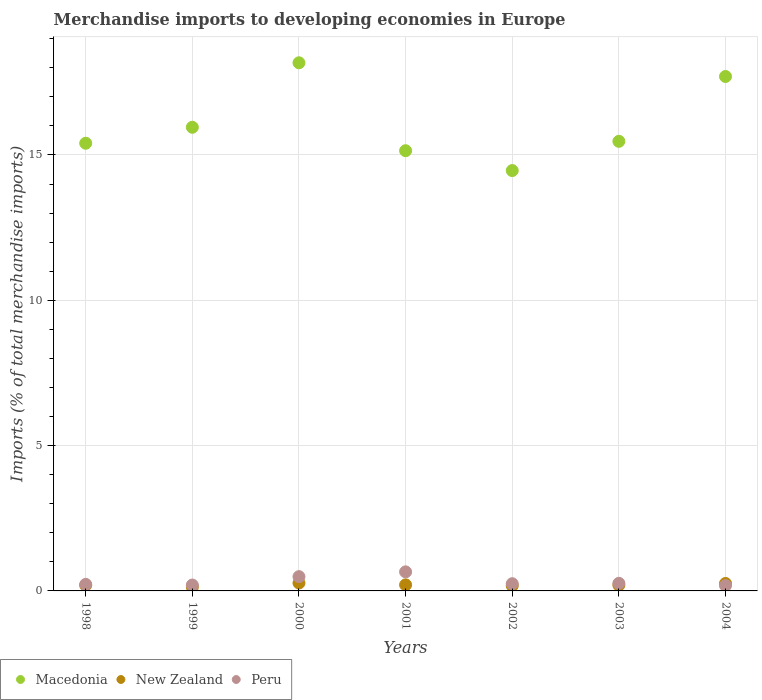How many different coloured dotlines are there?
Your answer should be compact. 3. Is the number of dotlines equal to the number of legend labels?
Your response must be concise. Yes. What is the percentage total merchandise imports in Macedonia in 2003?
Provide a short and direct response. 15.47. Across all years, what is the maximum percentage total merchandise imports in Peru?
Make the answer very short. 0.66. Across all years, what is the minimum percentage total merchandise imports in New Zealand?
Provide a succinct answer. 0.13. What is the total percentage total merchandise imports in Peru in the graph?
Your answer should be compact. 2.27. What is the difference between the percentage total merchandise imports in New Zealand in 1999 and that in 2002?
Your response must be concise. -0.05. What is the difference between the percentage total merchandise imports in Peru in 2002 and the percentage total merchandise imports in Macedonia in 2001?
Your answer should be very brief. -14.9. What is the average percentage total merchandise imports in Macedonia per year?
Your response must be concise. 16.04. In the year 2004, what is the difference between the percentage total merchandise imports in New Zealand and percentage total merchandise imports in Macedonia?
Your answer should be very brief. -17.44. In how many years, is the percentage total merchandise imports in Peru greater than 3 %?
Offer a very short reply. 0. What is the ratio of the percentage total merchandise imports in Macedonia in 1999 to that in 2004?
Your response must be concise. 0.9. What is the difference between the highest and the second highest percentage total merchandise imports in Peru?
Your answer should be very brief. 0.16. What is the difference between the highest and the lowest percentage total merchandise imports in Peru?
Make the answer very short. 0.47. In how many years, is the percentage total merchandise imports in New Zealand greater than the average percentage total merchandise imports in New Zealand taken over all years?
Your response must be concise. 3. Is the sum of the percentage total merchandise imports in Macedonia in 1999 and 2002 greater than the maximum percentage total merchandise imports in New Zealand across all years?
Provide a short and direct response. Yes. Is it the case that in every year, the sum of the percentage total merchandise imports in New Zealand and percentage total merchandise imports in Macedonia  is greater than the percentage total merchandise imports in Peru?
Give a very brief answer. Yes. Does the percentage total merchandise imports in New Zealand monotonically increase over the years?
Your answer should be compact. No. Are the values on the major ticks of Y-axis written in scientific E-notation?
Offer a very short reply. No. Does the graph contain any zero values?
Your response must be concise. No. Where does the legend appear in the graph?
Ensure brevity in your answer.  Bottom left. What is the title of the graph?
Provide a short and direct response. Merchandise imports to developing economies in Europe. Does "Belarus" appear as one of the legend labels in the graph?
Give a very brief answer. No. What is the label or title of the Y-axis?
Offer a terse response. Imports (% of total merchandise imports). What is the Imports (% of total merchandise imports) of Macedonia in 1998?
Ensure brevity in your answer.  15.4. What is the Imports (% of total merchandise imports) of New Zealand in 1998?
Provide a short and direct response. 0.19. What is the Imports (% of total merchandise imports) in Peru in 1998?
Ensure brevity in your answer.  0.23. What is the Imports (% of total merchandise imports) of Macedonia in 1999?
Offer a very short reply. 15.95. What is the Imports (% of total merchandise imports) in New Zealand in 1999?
Give a very brief answer. 0.13. What is the Imports (% of total merchandise imports) in Peru in 1999?
Make the answer very short. 0.2. What is the Imports (% of total merchandise imports) in Macedonia in 2000?
Offer a terse response. 18.17. What is the Imports (% of total merchandise imports) in New Zealand in 2000?
Give a very brief answer. 0.27. What is the Imports (% of total merchandise imports) in Peru in 2000?
Offer a terse response. 0.49. What is the Imports (% of total merchandise imports) of Macedonia in 2001?
Offer a very short reply. 15.15. What is the Imports (% of total merchandise imports) of New Zealand in 2001?
Your answer should be very brief. 0.21. What is the Imports (% of total merchandise imports) in Peru in 2001?
Your answer should be compact. 0.66. What is the Imports (% of total merchandise imports) in Macedonia in 2002?
Your answer should be compact. 14.46. What is the Imports (% of total merchandise imports) in New Zealand in 2002?
Give a very brief answer. 0.18. What is the Imports (% of total merchandise imports) of Peru in 2002?
Offer a terse response. 0.25. What is the Imports (% of total merchandise imports) in Macedonia in 2003?
Offer a terse response. 15.47. What is the Imports (% of total merchandise imports) in New Zealand in 2003?
Offer a very short reply. 0.2. What is the Imports (% of total merchandise imports) of Peru in 2003?
Your answer should be compact. 0.26. What is the Imports (% of total merchandise imports) of Macedonia in 2004?
Your response must be concise. 17.7. What is the Imports (% of total merchandise imports) in New Zealand in 2004?
Provide a short and direct response. 0.26. What is the Imports (% of total merchandise imports) of Peru in 2004?
Give a very brief answer. 0.18. Across all years, what is the maximum Imports (% of total merchandise imports) of Macedonia?
Your answer should be very brief. 18.17. Across all years, what is the maximum Imports (% of total merchandise imports) of New Zealand?
Offer a very short reply. 0.27. Across all years, what is the maximum Imports (% of total merchandise imports) in Peru?
Your answer should be compact. 0.66. Across all years, what is the minimum Imports (% of total merchandise imports) of Macedonia?
Your answer should be compact. 14.46. Across all years, what is the minimum Imports (% of total merchandise imports) in New Zealand?
Offer a terse response. 0.13. Across all years, what is the minimum Imports (% of total merchandise imports) of Peru?
Your answer should be compact. 0.18. What is the total Imports (% of total merchandise imports) in Macedonia in the graph?
Offer a very short reply. 112.31. What is the total Imports (% of total merchandise imports) of New Zealand in the graph?
Offer a terse response. 1.44. What is the total Imports (% of total merchandise imports) of Peru in the graph?
Ensure brevity in your answer.  2.27. What is the difference between the Imports (% of total merchandise imports) in Macedonia in 1998 and that in 1999?
Give a very brief answer. -0.55. What is the difference between the Imports (% of total merchandise imports) of New Zealand in 1998 and that in 1999?
Keep it short and to the point. 0.06. What is the difference between the Imports (% of total merchandise imports) in Peru in 1998 and that in 1999?
Offer a terse response. 0.02. What is the difference between the Imports (% of total merchandise imports) of Macedonia in 1998 and that in 2000?
Make the answer very short. -2.77. What is the difference between the Imports (% of total merchandise imports) in New Zealand in 1998 and that in 2000?
Offer a terse response. -0.08. What is the difference between the Imports (% of total merchandise imports) in Peru in 1998 and that in 2000?
Offer a very short reply. -0.27. What is the difference between the Imports (% of total merchandise imports) of Macedonia in 1998 and that in 2001?
Your answer should be compact. 0.26. What is the difference between the Imports (% of total merchandise imports) of New Zealand in 1998 and that in 2001?
Give a very brief answer. -0.01. What is the difference between the Imports (% of total merchandise imports) of Peru in 1998 and that in 2001?
Your answer should be very brief. -0.43. What is the difference between the Imports (% of total merchandise imports) in Macedonia in 1998 and that in 2002?
Offer a terse response. 0.94. What is the difference between the Imports (% of total merchandise imports) in New Zealand in 1998 and that in 2002?
Your answer should be compact. 0.01. What is the difference between the Imports (% of total merchandise imports) in Peru in 1998 and that in 2002?
Ensure brevity in your answer.  -0.02. What is the difference between the Imports (% of total merchandise imports) in Macedonia in 1998 and that in 2003?
Make the answer very short. -0.07. What is the difference between the Imports (% of total merchandise imports) of New Zealand in 1998 and that in 2003?
Provide a succinct answer. -0. What is the difference between the Imports (% of total merchandise imports) in Peru in 1998 and that in 2003?
Make the answer very short. -0.04. What is the difference between the Imports (% of total merchandise imports) of Macedonia in 1998 and that in 2004?
Provide a succinct answer. -2.3. What is the difference between the Imports (% of total merchandise imports) of New Zealand in 1998 and that in 2004?
Ensure brevity in your answer.  -0.06. What is the difference between the Imports (% of total merchandise imports) in Peru in 1998 and that in 2004?
Provide a succinct answer. 0.04. What is the difference between the Imports (% of total merchandise imports) in Macedonia in 1999 and that in 2000?
Offer a terse response. -2.22. What is the difference between the Imports (% of total merchandise imports) in New Zealand in 1999 and that in 2000?
Provide a succinct answer. -0.14. What is the difference between the Imports (% of total merchandise imports) in Peru in 1999 and that in 2000?
Your answer should be compact. -0.29. What is the difference between the Imports (% of total merchandise imports) in Macedonia in 1999 and that in 2001?
Offer a very short reply. 0.81. What is the difference between the Imports (% of total merchandise imports) in New Zealand in 1999 and that in 2001?
Give a very brief answer. -0.08. What is the difference between the Imports (% of total merchandise imports) in Peru in 1999 and that in 2001?
Offer a terse response. -0.45. What is the difference between the Imports (% of total merchandise imports) in Macedonia in 1999 and that in 2002?
Your answer should be compact. 1.49. What is the difference between the Imports (% of total merchandise imports) in New Zealand in 1999 and that in 2002?
Provide a short and direct response. -0.05. What is the difference between the Imports (% of total merchandise imports) of Peru in 1999 and that in 2002?
Offer a terse response. -0.05. What is the difference between the Imports (% of total merchandise imports) of Macedonia in 1999 and that in 2003?
Offer a terse response. 0.48. What is the difference between the Imports (% of total merchandise imports) of New Zealand in 1999 and that in 2003?
Your response must be concise. -0.07. What is the difference between the Imports (% of total merchandise imports) of Peru in 1999 and that in 2003?
Your answer should be compact. -0.06. What is the difference between the Imports (% of total merchandise imports) in Macedonia in 1999 and that in 2004?
Offer a terse response. -1.75. What is the difference between the Imports (% of total merchandise imports) in New Zealand in 1999 and that in 2004?
Make the answer very short. -0.12. What is the difference between the Imports (% of total merchandise imports) of Peru in 1999 and that in 2004?
Provide a short and direct response. 0.02. What is the difference between the Imports (% of total merchandise imports) in Macedonia in 2000 and that in 2001?
Your answer should be very brief. 3.03. What is the difference between the Imports (% of total merchandise imports) of New Zealand in 2000 and that in 2001?
Give a very brief answer. 0.06. What is the difference between the Imports (% of total merchandise imports) of Peru in 2000 and that in 2001?
Provide a succinct answer. -0.16. What is the difference between the Imports (% of total merchandise imports) of Macedonia in 2000 and that in 2002?
Give a very brief answer. 3.71. What is the difference between the Imports (% of total merchandise imports) in New Zealand in 2000 and that in 2002?
Offer a terse response. 0.09. What is the difference between the Imports (% of total merchandise imports) in Peru in 2000 and that in 2002?
Give a very brief answer. 0.24. What is the difference between the Imports (% of total merchandise imports) of Macedonia in 2000 and that in 2003?
Offer a very short reply. 2.7. What is the difference between the Imports (% of total merchandise imports) of New Zealand in 2000 and that in 2003?
Keep it short and to the point. 0.07. What is the difference between the Imports (% of total merchandise imports) of Peru in 2000 and that in 2003?
Keep it short and to the point. 0.23. What is the difference between the Imports (% of total merchandise imports) in Macedonia in 2000 and that in 2004?
Make the answer very short. 0.47. What is the difference between the Imports (% of total merchandise imports) of New Zealand in 2000 and that in 2004?
Keep it short and to the point. 0.02. What is the difference between the Imports (% of total merchandise imports) of Peru in 2000 and that in 2004?
Make the answer very short. 0.31. What is the difference between the Imports (% of total merchandise imports) of Macedonia in 2001 and that in 2002?
Offer a very short reply. 0.68. What is the difference between the Imports (% of total merchandise imports) of New Zealand in 2001 and that in 2002?
Your response must be concise. 0.03. What is the difference between the Imports (% of total merchandise imports) in Peru in 2001 and that in 2002?
Your response must be concise. 0.41. What is the difference between the Imports (% of total merchandise imports) in Macedonia in 2001 and that in 2003?
Keep it short and to the point. -0.32. What is the difference between the Imports (% of total merchandise imports) of New Zealand in 2001 and that in 2003?
Make the answer very short. 0.01. What is the difference between the Imports (% of total merchandise imports) in Peru in 2001 and that in 2003?
Provide a succinct answer. 0.39. What is the difference between the Imports (% of total merchandise imports) of Macedonia in 2001 and that in 2004?
Your answer should be very brief. -2.55. What is the difference between the Imports (% of total merchandise imports) of New Zealand in 2001 and that in 2004?
Ensure brevity in your answer.  -0.05. What is the difference between the Imports (% of total merchandise imports) in Peru in 2001 and that in 2004?
Offer a terse response. 0.47. What is the difference between the Imports (% of total merchandise imports) of Macedonia in 2002 and that in 2003?
Offer a very short reply. -1.01. What is the difference between the Imports (% of total merchandise imports) of New Zealand in 2002 and that in 2003?
Keep it short and to the point. -0.02. What is the difference between the Imports (% of total merchandise imports) of Peru in 2002 and that in 2003?
Offer a very short reply. -0.01. What is the difference between the Imports (% of total merchandise imports) of Macedonia in 2002 and that in 2004?
Provide a succinct answer. -3.24. What is the difference between the Imports (% of total merchandise imports) in New Zealand in 2002 and that in 2004?
Your answer should be very brief. -0.08. What is the difference between the Imports (% of total merchandise imports) of Peru in 2002 and that in 2004?
Provide a short and direct response. 0.06. What is the difference between the Imports (% of total merchandise imports) in Macedonia in 2003 and that in 2004?
Give a very brief answer. -2.23. What is the difference between the Imports (% of total merchandise imports) in New Zealand in 2003 and that in 2004?
Offer a terse response. -0.06. What is the difference between the Imports (% of total merchandise imports) in Peru in 2003 and that in 2004?
Offer a terse response. 0.08. What is the difference between the Imports (% of total merchandise imports) in Macedonia in 1998 and the Imports (% of total merchandise imports) in New Zealand in 1999?
Your answer should be compact. 15.27. What is the difference between the Imports (% of total merchandise imports) in Macedonia in 1998 and the Imports (% of total merchandise imports) in Peru in 1999?
Provide a succinct answer. 15.2. What is the difference between the Imports (% of total merchandise imports) of New Zealand in 1998 and the Imports (% of total merchandise imports) of Peru in 1999?
Keep it short and to the point. -0.01. What is the difference between the Imports (% of total merchandise imports) in Macedonia in 1998 and the Imports (% of total merchandise imports) in New Zealand in 2000?
Ensure brevity in your answer.  15.13. What is the difference between the Imports (% of total merchandise imports) of Macedonia in 1998 and the Imports (% of total merchandise imports) of Peru in 2000?
Provide a succinct answer. 14.91. What is the difference between the Imports (% of total merchandise imports) of New Zealand in 1998 and the Imports (% of total merchandise imports) of Peru in 2000?
Offer a terse response. -0.3. What is the difference between the Imports (% of total merchandise imports) in Macedonia in 1998 and the Imports (% of total merchandise imports) in New Zealand in 2001?
Give a very brief answer. 15.19. What is the difference between the Imports (% of total merchandise imports) of Macedonia in 1998 and the Imports (% of total merchandise imports) of Peru in 2001?
Provide a short and direct response. 14.75. What is the difference between the Imports (% of total merchandise imports) of New Zealand in 1998 and the Imports (% of total merchandise imports) of Peru in 2001?
Your response must be concise. -0.46. What is the difference between the Imports (% of total merchandise imports) in Macedonia in 1998 and the Imports (% of total merchandise imports) in New Zealand in 2002?
Give a very brief answer. 15.22. What is the difference between the Imports (% of total merchandise imports) of Macedonia in 1998 and the Imports (% of total merchandise imports) of Peru in 2002?
Offer a very short reply. 15.16. What is the difference between the Imports (% of total merchandise imports) of New Zealand in 1998 and the Imports (% of total merchandise imports) of Peru in 2002?
Your answer should be compact. -0.05. What is the difference between the Imports (% of total merchandise imports) in Macedonia in 1998 and the Imports (% of total merchandise imports) in New Zealand in 2003?
Keep it short and to the point. 15.21. What is the difference between the Imports (% of total merchandise imports) of Macedonia in 1998 and the Imports (% of total merchandise imports) of Peru in 2003?
Offer a terse response. 15.14. What is the difference between the Imports (% of total merchandise imports) of New Zealand in 1998 and the Imports (% of total merchandise imports) of Peru in 2003?
Your answer should be compact. -0.07. What is the difference between the Imports (% of total merchandise imports) of Macedonia in 1998 and the Imports (% of total merchandise imports) of New Zealand in 2004?
Your response must be concise. 15.15. What is the difference between the Imports (% of total merchandise imports) of Macedonia in 1998 and the Imports (% of total merchandise imports) of Peru in 2004?
Offer a terse response. 15.22. What is the difference between the Imports (% of total merchandise imports) in New Zealand in 1998 and the Imports (% of total merchandise imports) in Peru in 2004?
Provide a short and direct response. 0.01. What is the difference between the Imports (% of total merchandise imports) in Macedonia in 1999 and the Imports (% of total merchandise imports) in New Zealand in 2000?
Offer a terse response. 15.68. What is the difference between the Imports (% of total merchandise imports) in Macedonia in 1999 and the Imports (% of total merchandise imports) in Peru in 2000?
Offer a terse response. 15.46. What is the difference between the Imports (% of total merchandise imports) of New Zealand in 1999 and the Imports (% of total merchandise imports) of Peru in 2000?
Your answer should be very brief. -0.36. What is the difference between the Imports (% of total merchandise imports) in Macedonia in 1999 and the Imports (% of total merchandise imports) in New Zealand in 2001?
Provide a succinct answer. 15.74. What is the difference between the Imports (% of total merchandise imports) in Macedonia in 1999 and the Imports (% of total merchandise imports) in Peru in 2001?
Keep it short and to the point. 15.3. What is the difference between the Imports (% of total merchandise imports) of New Zealand in 1999 and the Imports (% of total merchandise imports) of Peru in 2001?
Give a very brief answer. -0.52. What is the difference between the Imports (% of total merchandise imports) in Macedonia in 1999 and the Imports (% of total merchandise imports) in New Zealand in 2002?
Provide a short and direct response. 15.77. What is the difference between the Imports (% of total merchandise imports) in Macedonia in 1999 and the Imports (% of total merchandise imports) in Peru in 2002?
Your response must be concise. 15.7. What is the difference between the Imports (% of total merchandise imports) in New Zealand in 1999 and the Imports (% of total merchandise imports) in Peru in 2002?
Your response must be concise. -0.12. What is the difference between the Imports (% of total merchandise imports) of Macedonia in 1999 and the Imports (% of total merchandise imports) of New Zealand in 2003?
Provide a succinct answer. 15.75. What is the difference between the Imports (% of total merchandise imports) of Macedonia in 1999 and the Imports (% of total merchandise imports) of Peru in 2003?
Your answer should be compact. 15.69. What is the difference between the Imports (% of total merchandise imports) of New Zealand in 1999 and the Imports (% of total merchandise imports) of Peru in 2003?
Your answer should be very brief. -0.13. What is the difference between the Imports (% of total merchandise imports) in Macedonia in 1999 and the Imports (% of total merchandise imports) in New Zealand in 2004?
Your answer should be compact. 15.7. What is the difference between the Imports (% of total merchandise imports) of Macedonia in 1999 and the Imports (% of total merchandise imports) of Peru in 2004?
Your answer should be compact. 15.77. What is the difference between the Imports (% of total merchandise imports) of New Zealand in 1999 and the Imports (% of total merchandise imports) of Peru in 2004?
Keep it short and to the point. -0.05. What is the difference between the Imports (% of total merchandise imports) of Macedonia in 2000 and the Imports (% of total merchandise imports) of New Zealand in 2001?
Make the answer very short. 17.96. What is the difference between the Imports (% of total merchandise imports) in Macedonia in 2000 and the Imports (% of total merchandise imports) in Peru in 2001?
Offer a very short reply. 17.52. What is the difference between the Imports (% of total merchandise imports) of New Zealand in 2000 and the Imports (% of total merchandise imports) of Peru in 2001?
Keep it short and to the point. -0.38. What is the difference between the Imports (% of total merchandise imports) of Macedonia in 2000 and the Imports (% of total merchandise imports) of New Zealand in 2002?
Your answer should be compact. 17.99. What is the difference between the Imports (% of total merchandise imports) of Macedonia in 2000 and the Imports (% of total merchandise imports) of Peru in 2002?
Give a very brief answer. 17.92. What is the difference between the Imports (% of total merchandise imports) in New Zealand in 2000 and the Imports (% of total merchandise imports) in Peru in 2002?
Provide a succinct answer. 0.02. What is the difference between the Imports (% of total merchandise imports) in Macedonia in 2000 and the Imports (% of total merchandise imports) in New Zealand in 2003?
Keep it short and to the point. 17.97. What is the difference between the Imports (% of total merchandise imports) of Macedonia in 2000 and the Imports (% of total merchandise imports) of Peru in 2003?
Your response must be concise. 17.91. What is the difference between the Imports (% of total merchandise imports) in Macedonia in 2000 and the Imports (% of total merchandise imports) in New Zealand in 2004?
Keep it short and to the point. 17.92. What is the difference between the Imports (% of total merchandise imports) of Macedonia in 2000 and the Imports (% of total merchandise imports) of Peru in 2004?
Offer a very short reply. 17.99. What is the difference between the Imports (% of total merchandise imports) in New Zealand in 2000 and the Imports (% of total merchandise imports) in Peru in 2004?
Your answer should be very brief. 0.09. What is the difference between the Imports (% of total merchandise imports) of Macedonia in 2001 and the Imports (% of total merchandise imports) of New Zealand in 2002?
Offer a terse response. 14.97. What is the difference between the Imports (% of total merchandise imports) of Macedonia in 2001 and the Imports (% of total merchandise imports) of Peru in 2002?
Offer a very short reply. 14.9. What is the difference between the Imports (% of total merchandise imports) in New Zealand in 2001 and the Imports (% of total merchandise imports) in Peru in 2002?
Your answer should be compact. -0.04. What is the difference between the Imports (% of total merchandise imports) in Macedonia in 2001 and the Imports (% of total merchandise imports) in New Zealand in 2003?
Offer a very short reply. 14.95. What is the difference between the Imports (% of total merchandise imports) of Macedonia in 2001 and the Imports (% of total merchandise imports) of Peru in 2003?
Provide a short and direct response. 14.88. What is the difference between the Imports (% of total merchandise imports) of New Zealand in 2001 and the Imports (% of total merchandise imports) of Peru in 2003?
Provide a short and direct response. -0.05. What is the difference between the Imports (% of total merchandise imports) of Macedonia in 2001 and the Imports (% of total merchandise imports) of New Zealand in 2004?
Make the answer very short. 14.89. What is the difference between the Imports (% of total merchandise imports) in Macedonia in 2001 and the Imports (% of total merchandise imports) in Peru in 2004?
Your answer should be compact. 14.96. What is the difference between the Imports (% of total merchandise imports) of New Zealand in 2001 and the Imports (% of total merchandise imports) of Peru in 2004?
Provide a succinct answer. 0.03. What is the difference between the Imports (% of total merchandise imports) in Macedonia in 2002 and the Imports (% of total merchandise imports) in New Zealand in 2003?
Provide a succinct answer. 14.26. What is the difference between the Imports (% of total merchandise imports) in Macedonia in 2002 and the Imports (% of total merchandise imports) in Peru in 2003?
Offer a very short reply. 14.2. What is the difference between the Imports (% of total merchandise imports) in New Zealand in 2002 and the Imports (% of total merchandise imports) in Peru in 2003?
Your answer should be compact. -0.08. What is the difference between the Imports (% of total merchandise imports) of Macedonia in 2002 and the Imports (% of total merchandise imports) of New Zealand in 2004?
Your answer should be compact. 14.21. What is the difference between the Imports (% of total merchandise imports) of Macedonia in 2002 and the Imports (% of total merchandise imports) of Peru in 2004?
Your response must be concise. 14.28. What is the difference between the Imports (% of total merchandise imports) of New Zealand in 2002 and the Imports (% of total merchandise imports) of Peru in 2004?
Your answer should be compact. -0. What is the difference between the Imports (% of total merchandise imports) in Macedonia in 2003 and the Imports (% of total merchandise imports) in New Zealand in 2004?
Your answer should be very brief. 15.21. What is the difference between the Imports (% of total merchandise imports) in Macedonia in 2003 and the Imports (% of total merchandise imports) in Peru in 2004?
Offer a terse response. 15.29. What is the difference between the Imports (% of total merchandise imports) in New Zealand in 2003 and the Imports (% of total merchandise imports) in Peru in 2004?
Provide a short and direct response. 0.01. What is the average Imports (% of total merchandise imports) in Macedonia per year?
Keep it short and to the point. 16.04. What is the average Imports (% of total merchandise imports) in New Zealand per year?
Ensure brevity in your answer.  0.21. What is the average Imports (% of total merchandise imports) in Peru per year?
Your answer should be compact. 0.32. In the year 1998, what is the difference between the Imports (% of total merchandise imports) of Macedonia and Imports (% of total merchandise imports) of New Zealand?
Offer a very short reply. 15.21. In the year 1998, what is the difference between the Imports (% of total merchandise imports) of Macedonia and Imports (% of total merchandise imports) of Peru?
Provide a short and direct response. 15.18. In the year 1998, what is the difference between the Imports (% of total merchandise imports) of New Zealand and Imports (% of total merchandise imports) of Peru?
Offer a terse response. -0.03. In the year 1999, what is the difference between the Imports (% of total merchandise imports) in Macedonia and Imports (% of total merchandise imports) in New Zealand?
Ensure brevity in your answer.  15.82. In the year 1999, what is the difference between the Imports (% of total merchandise imports) in Macedonia and Imports (% of total merchandise imports) in Peru?
Your response must be concise. 15.75. In the year 1999, what is the difference between the Imports (% of total merchandise imports) in New Zealand and Imports (% of total merchandise imports) in Peru?
Provide a short and direct response. -0.07. In the year 2000, what is the difference between the Imports (% of total merchandise imports) of Macedonia and Imports (% of total merchandise imports) of New Zealand?
Your response must be concise. 17.9. In the year 2000, what is the difference between the Imports (% of total merchandise imports) in Macedonia and Imports (% of total merchandise imports) in Peru?
Ensure brevity in your answer.  17.68. In the year 2000, what is the difference between the Imports (% of total merchandise imports) of New Zealand and Imports (% of total merchandise imports) of Peru?
Offer a very short reply. -0.22. In the year 2001, what is the difference between the Imports (% of total merchandise imports) in Macedonia and Imports (% of total merchandise imports) in New Zealand?
Give a very brief answer. 14.94. In the year 2001, what is the difference between the Imports (% of total merchandise imports) of Macedonia and Imports (% of total merchandise imports) of Peru?
Provide a short and direct response. 14.49. In the year 2001, what is the difference between the Imports (% of total merchandise imports) of New Zealand and Imports (% of total merchandise imports) of Peru?
Offer a very short reply. -0.45. In the year 2002, what is the difference between the Imports (% of total merchandise imports) of Macedonia and Imports (% of total merchandise imports) of New Zealand?
Provide a short and direct response. 14.28. In the year 2002, what is the difference between the Imports (% of total merchandise imports) in Macedonia and Imports (% of total merchandise imports) in Peru?
Your answer should be very brief. 14.22. In the year 2002, what is the difference between the Imports (% of total merchandise imports) of New Zealand and Imports (% of total merchandise imports) of Peru?
Your answer should be very brief. -0.07. In the year 2003, what is the difference between the Imports (% of total merchandise imports) in Macedonia and Imports (% of total merchandise imports) in New Zealand?
Keep it short and to the point. 15.27. In the year 2003, what is the difference between the Imports (% of total merchandise imports) of Macedonia and Imports (% of total merchandise imports) of Peru?
Your response must be concise. 15.21. In the year 2003, what is the difference between the Imports (% of total merchandise imports) of New Zealand and Imports (% of total merchandise imports) of Peru?
Your answer should be compact. -0.06. In the year 2004, what is the difference between the Imports (% of total merchandise imports) in Macedonia and Imports (% of total merchandise imports) in New Zealand?
Keep it short and to the point. 17.44. In the year 2004, what is the difference between the Imports (% of total merchandise imports) of Macedonia and Imports (% of total merchandise imports) of Peru?
Your answer should be very brief. 17.52. In the year 2004, what is the difference between the Imports (% of total merchandise imports) in New Zealand and Imports (% of total merchandise imports) in Peru?
Provide a short and direct response. 0.07. What is the ratio of the Imports (% of total merchandise imports) in Macedonia in 1998 to that in 1999?
Give a very brief answer. 0.97. What is the ratio of the Imports (% of total merchandise imports) in New Zealand in 1998 to that in 1999?
Ensure brevity in your answer.  1.46. What is the ratio of the Imports (% of total merchandise imports) of Peru in 1998 to that in 1999?
Offer a very short reply. 1.11. What is the ratio of the Imports (% of total merchandise imports) in Macedonia in 1998 to that in 2000?
Keep it short and to the point. 0.85. What is the ratio of the Imports (% of total merchandise imports) of New Zealand in 1998 to that in 2000?
Provide a succinct answer. 0.71. What is the ratio of the Imports (% of total merchandise imports) of Peru in 1998 to that in 2000?
Your answer should be very brief. 0.46. What is the ratio of the Imports (% of total merchandise imports) of Macedonia in 1998 to that in 2001?
Keep it short and to the point. 1.02. What is the ratio of the Imports (% of total merchandise imports) of New Zealand in 1998 to that in 2001?
Your answer should be compact. 0.93. What is the ratio of the Imports (% of total merchandise imports) of Peru in 1998 to that in 2001?
Make the answer very short. 0.34. What is the ratio of the Imports (% of total merchandise imports) of Macedonia in 1998 to that in 2002?
Your answer should be very brief. 1.06. What is the ratio of the Imports (% of total merchandise imports) of New Zealand in 1998 to that in 2002?
Keep it short and to the point. 1.07. What is the ratio of the Imports (% of total merchandise imports) of Peru in 1998 to that in 2002?
Give a very brief answer. 0.91. What is the ratio of the Imports (% of total merchandise imports) of New Zealand in 1998 to that in 2003?
Keep it short and to the point. 0.98. What is the ratio of the Imports (% of total merchandise imports) of Peru in 1998 to that in 2003?
Provide a short and direct response. 0.86. What is the ratio of the Imports (% of total merchandise imports) of Macedonia in 1998 to that in 2004?
Offer a terse response. 0.87. What is the ratio of the Imports (% of total merchandise imports) of New Zealand in 1998 to that in 2004?
Provide a short and direct response. 0.76. What is the ratio of the Imports (% of total merchandise imports) in Peru in 1998 to that in 2004?
Your response must be concise. 1.23. What is the ratio of the Imports (% of total merchandise imports) of Macedonia in 1999 to that in 2000?
Give a very brief answer. 0.88. What is the ratio of the Imports (% of total merchandise imports) in New Zealand in 1999 to that in 2000?
Offer a very short reply. 0.49. What is the ratio of the Imports (% of total merchandise imports) in Peru in 1999 to that in 2000?
Your response must be concise. 0.41. What is the ratio of the Imports (% of total merchandise imports) of Macedonia in 1999 to that in 2001?
Offer a very short reply. 1.05. What is the ratio of the Imports (% of total merchandise imports) of New Zealand in 1999 to that in 2001?
Provide a short and direct response. 0.64. What is the ratio of the Imports (% of total merchandise imports) in Peru in 1999 to that in 2001?
Ensure brevity in your answer.  0.31. What is the ratio of the Imports (% of total merchandise imports) in Macedonia in 1999 to that in 2002?
Your response must be concise. 1.1. What is the ratio of the Imports (% of total merchandise imports) of New Zealand in 1999 to that in 2002?
Offer a terse response. 0.74. What is the ratio of the Imports (% of total merchandise imports) of Peru in 1999 to that in 2002?
Provide a succinct answer. 0.82. What is the ratio of the Imports (% of total merchandise imports) of Macedonia in 1999 to that in 2003?
Your answer should be compact. 1.03. What is the ratio of the Imports (% of total merchandise imports) in New Zealand in 1999 to that in 2003?
Give a very brief answer. 0.67. What is the ratio of the Imports (% of total merchandise imports) in Peru in 1999 to that in 2003?
Your response must be concise. 0.78. What is the ratio of the Imports (% of total merchandise imports) of Macedonia in 1999 to that in 2004?
Ensure brevity in your answer.  0.9. What is the ratio of the Imports (% of total merchandise imports) in New Zealand in 1999 to that in 2004?
Ensure brevity in your answer.  0.52. What is the ratio of the Imports (% of total merchandise imports) in Peru in 1999 to that in 2004?
Make the answer very short. 1.1. What is the ratio of the Imports (% of total merchandise imports) in Macedonia in 2000 to that in 2001?
Offer a very short reply. 1.2. What is the ratio of the Imports (% of total merchandise imports) of New Zealand in 2000 to that in 2001?
Provide a succinct answer. 1.3. What is the ratio of the Imports (% of total merchandise imports) in Peru in 2000 to that in 2001?
Your answer should be very brief. 0.75. What is the ratio of the Imports (% of total merchandise imports) of Macedonia in 2000 to that in 2002?
Make the answer very short. 1.26. What is the ratio of the Imports (% of total merchandise imports) of New Zealand in 2000 to that in 2002?
Offer a terse response. 1.5. What is the ratio of the Imports (% of total merchandise imports) in Peru in 2000 to that in 2002?
Your answer should be compact. 1.98. What is the ratio of the Imports (% of total merchandise imports) in Macedonia in 2000 to that in 2003?
Your answer should be compact. 1.17. What is the ratio of the Imports (% of total merchandise imports) of New Zealand in 2000 to that in 2003?
Your answer should be very brief. 1.37. What is the ratio of the Imports (% of total merchandise imports) in Peru in 2000 to that in 2003?
Your answer should be very brief. 1.88. What is the ratio of the Imports (% of total merchandise imports) in Macedonia in 2000 to that in 2004?
Keep it short and to the point. 1.03. What is the ratio of the Imports (% of total merchandise imports) in New Zealand in 2000 to that in 2004?
Offer a terse response. 1.06. What is the ratio of the Imports (% of total merchandise imports) of Peru in 2000 to that in 2004?
Keep it short and to the point. 2.67. What is the ratio of the Imports (% of total merchandise imports) in Macedonia in 2001 to that in 2002?
Your answer should be very brief. 1.05. What is the ratio of the Imports (% of total merchandise imports) of New Zealand in 2001 to that in 2002?
Make the answer very short. 1.16. What is the ratio of the Imports (% of total merchandise imports) of Peru in 2001 to that in 2002?
Keep it short and to the point. 2.64. What is the ratio of the Imports (% of total merchandise imports) in Macedonia in 2001 to that in 2003?
Keep it short and to the point. 0.98. What is the ratio of the Imports (% of total merchandise imports) of New Zealand in 2001 to that in 2003?
Your response must be concise. 1.05. What is the ratio of the Imports (% of total merchandise imports) in Peru in 2001 to that in 2003?
Your answer should be compact. 2.51. What is the ratio of the Imports (% of total merchandise imports) in Macedonia in 2001 to that in 2004?
Your answer should be very brief. 0.86. What is the ratio of the Imports (% of total merchandise imports) of New Zealand in 2001 to that in 2004?
Offer a very short reply. 0.81. What is the ratio of the Imports (% of total merchandise imports) in Peru in 2001 to that in 2004?
Offer a very short reply. 3.57. What is the ratio of the Imports (% of total merchandise imports) of Macedonia in 2002 to that in 2003?
Your answer should be very brief. 0.94. What is the ratio of the Imports (% of total merchandise imports) of New Zealand in 2002 to that in 2003?
Your response must be concise. 0.91. What is the ratio of the Imports (% of total merchandise imports) in Peru in 2002 to that in 2003?
Make the answer very short. 0.95. What is the ratio of the Imports (% of total merchandise imports) of Macedonia in 2002 to that in 2004?
Offer a very short reply. 0.82. What is the ratio of the Imports (% of total merchandise imports) of New Zealand in 2002 to that in 2004?
Give a very brief answer. 0.7. What is the ratio of the Imports (% of total merchandise imports) in Peru in 2002 to that in 2004?
Keep it short and to the point. 1.35. What is the ratio of the Imports (% of total merchandise imports) of Macedonia in 2003 to that in 2004?
Keep it short and to the point. 0.87. What is the ratio of the Imports (% of total merchandise imports) in New Zealand in 2003 to that in 2004?
Provide a short and direct response. 0.77. What is the ratio of the Imports (% of total merchandise imports) of Peru in 2003 to that in 2004?
Your answer should be very brief. 1.42. What is the difference between the highest and the second highest Imports (% of total merchandise imports) of Macedonia?
Your answer should be compact. 0.47. What is the difference between the highest and the second highest Imports (% of total merchandise imports) in New Zealand?
Offer a terse response. 0.02. What is the difference between the highest and the second highest Imports (% of total merchandise imports) of Peru?
Your answer should be very brief. 0.16. What is the difference between the highest and the lowest Imports (% of total merchandise imports) of Macedonia?
Give a very brief answer. 3.71. What is the difference between the highest and the lowest Imports (% of total merchandise imports) of New Zealand?
Keep it short and to the point. 0.14. What is the difference between the highest and the lowest Imports (% of total merchandise imports) of Peru?
Offer a very short reply. 0.47. 